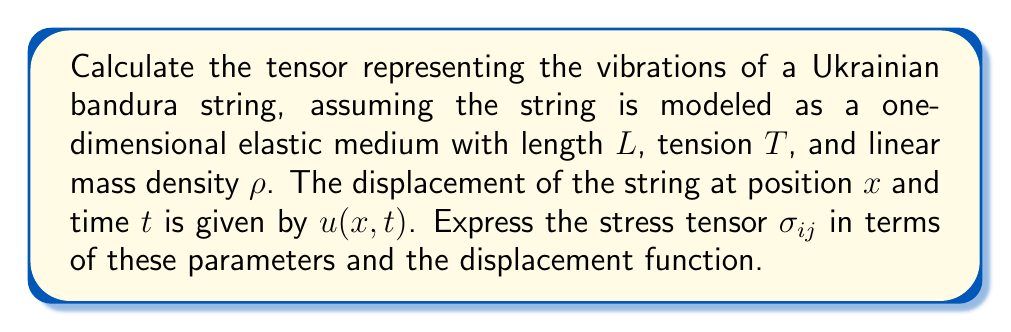Teach me how to tackle this problem. To solve this problem, we'll follow these steps:

1) First, recall that for a one-dimensional elastic medium like a string, the stress tensor $\sigma_{ij}$ reduces to a single component $\sigma_{xx}$.

2) The stress in a vibrating string is related to the strain by Hooke's law:

   $$\sigma_{xx} = E\epsilon_{xx}$$

   where $E$ is the Young's modulus and $\epsilon_{xx}$ is the strain.

3) For a string under tension $T$, the effective Young's modulus is given by:

   $$E = \frac{T}{A}$$

   where $A$ is the cross-sectional area of the string.

4) The strain $\epsilon_{xx}$ for small displacements is given by:

   $$\epsilon_{xx} = \frac{\partial u}{\partial x}$$

5) Substituting these into the stress equation:

   $$\sigma_{xx} = \frac{T}{A} \frac{\partial u}{\partial x}$$

6) The cross-sectional area $A$ can be expressed in terms of the linear mass density $\rho$ and the material density $\rho_m$:

   $$A = \frac{\rho}{\rho_m}$$

7) Substituting this into our stress equation:

   $$\sigma_{xx} = T\frac{\rho_m}{\rho} \frac{\partial u}{\partial x}$$

8) The material density $\rho_m$ can be eliminated by using the wave equation for a string:

   $$\frac{\partial^2 u}{\partial t^2} = \frac{T}{\rho} \frac{\partial^2 u}{\partial x^2}$$

   This implies that $\frac{T}{\rho} = c^2$, where $c$ is the wave speed.

9) Our final expression for the stress tensor becomes:

   $$\sigma_{xx} = \rho c^2 \frac{\partial u}{\partial x}$$

This is the tensor representing the vibrations of the bandura string.
Answer: $$\sigma_{xx} = \rho c^2 \frac{\partial u}{\partial x}$$ 